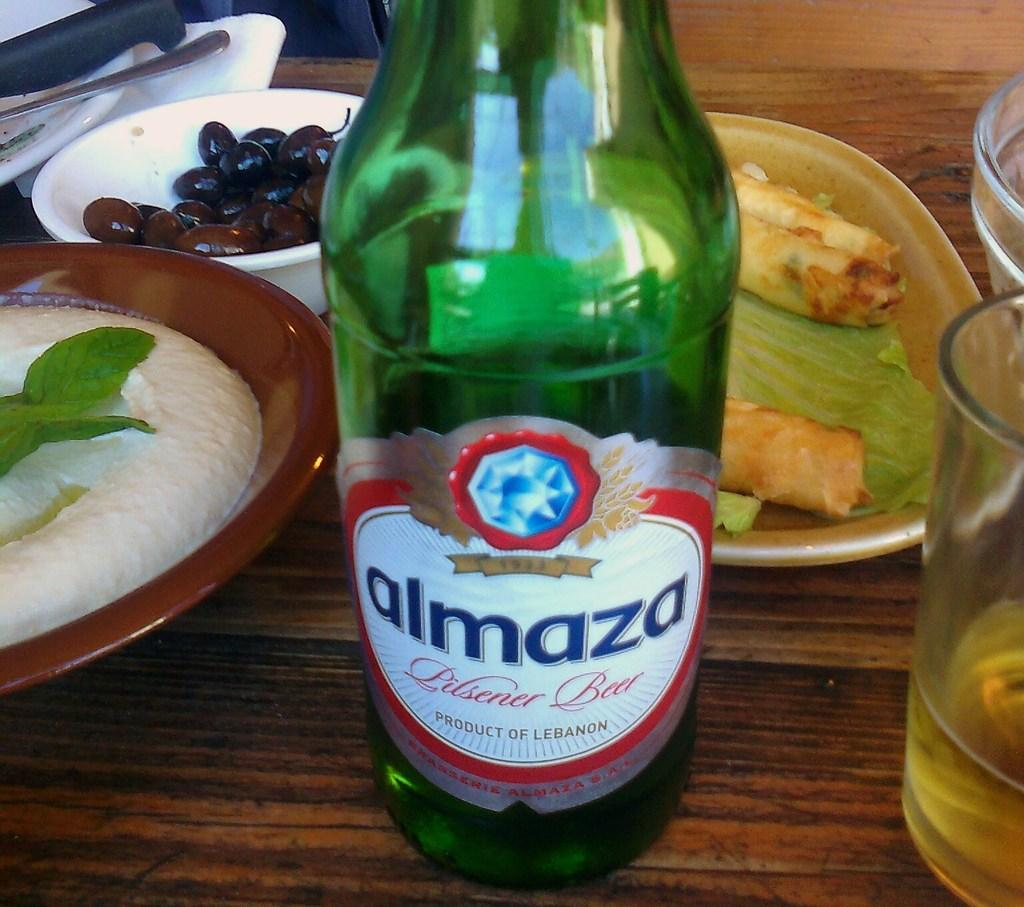<image>
Relay a brief, clear account of the picture shown. A green bottle of Almaza beer is near a meal on a table. 